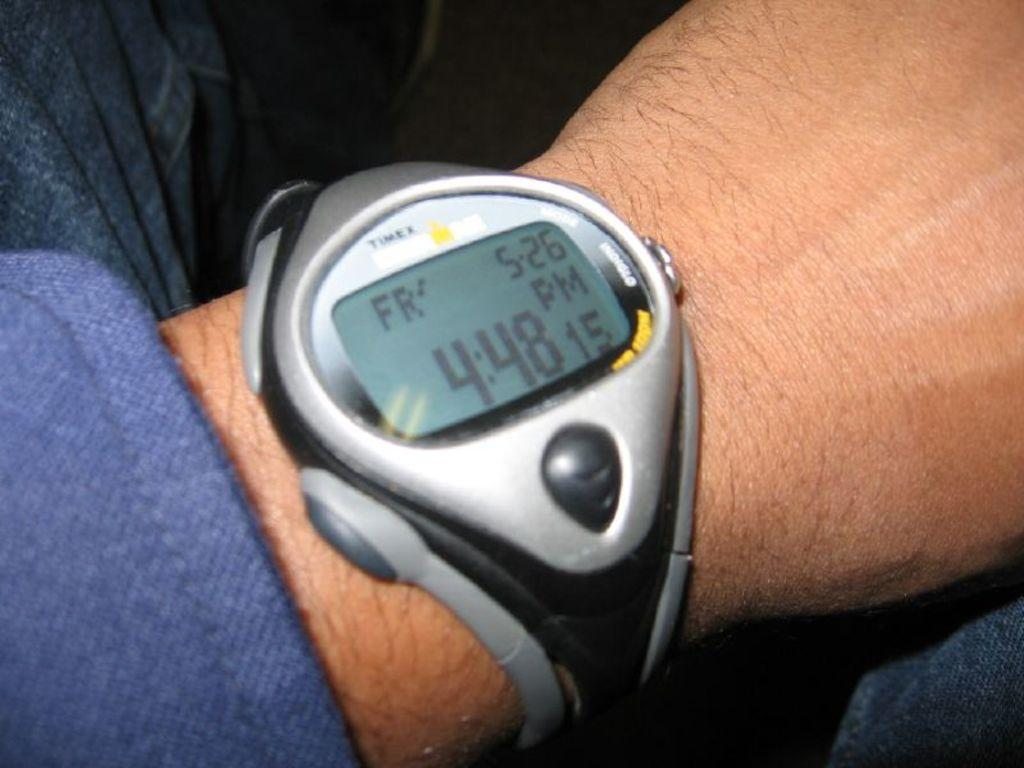<image>
Describe the image concisely. A person wearing a Timex digital watch showing 4:48 as the time 